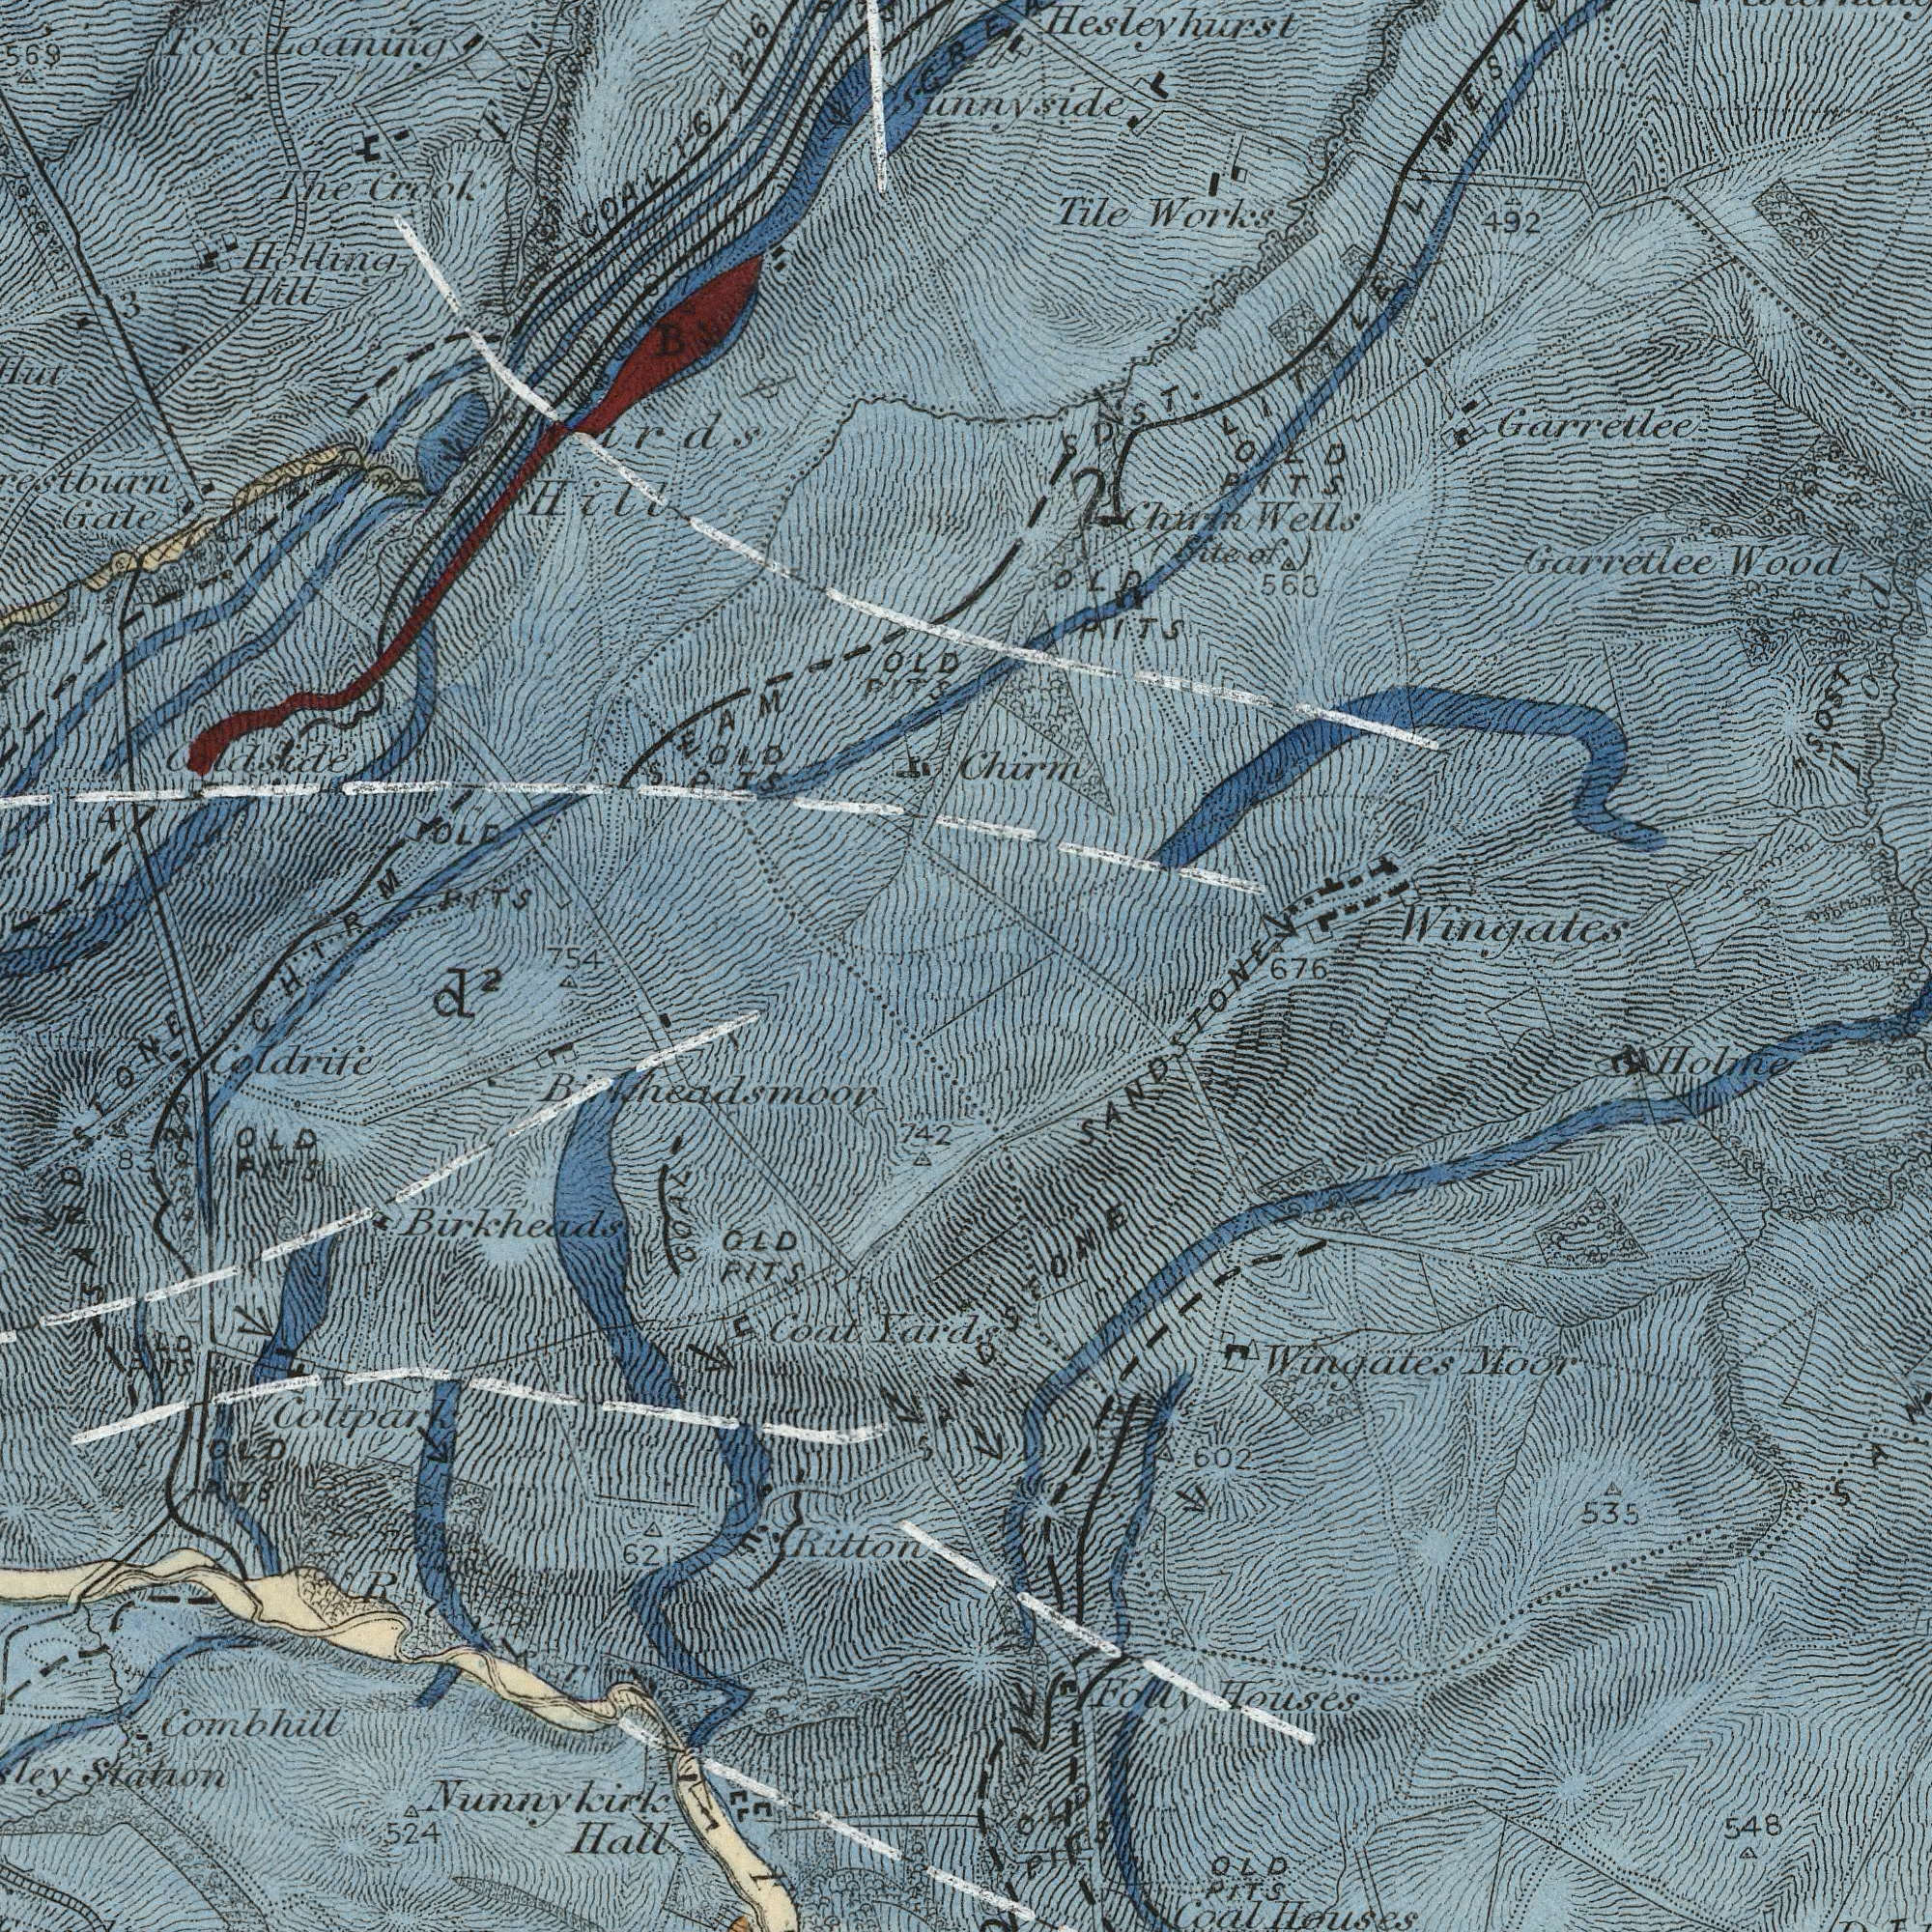What text appears in the top-right area of the image? Works Garretlee Wood Hesleyhurst Wingates Tile 492 568 SDST. Wells PITS Chirm LITTLE Sunnyside SDST PITS Garretlee Chirm OLD (Site OLD Tod of) What text can you see in the top-left section? Loaning Crook Hill Foot Gate Holling Hill The PITS 569 OLD 4 OLD 3 PITS SEAM Coldside COAL OLD 754 ###rds 6-2-6 PITS 617 B PITS CHIRM What text can you see in the bottom-left section? Coat Combhill Hall Yards Coltpark 524 PITS 742 Nunnykirk Ritton 621 PITS Station GOAL d<sup>2</sup> Coldrife OLD PITS Birkheads 83 OLD OLD OLD SANDSTONE PITS River What text is shown in the bottom-right quadrant? Moor 548 Wingates PITS 602 Folly 535 Houses Holine OLD Houses PITS SANDSTONE Coal OLD 676 SANDSTONE 